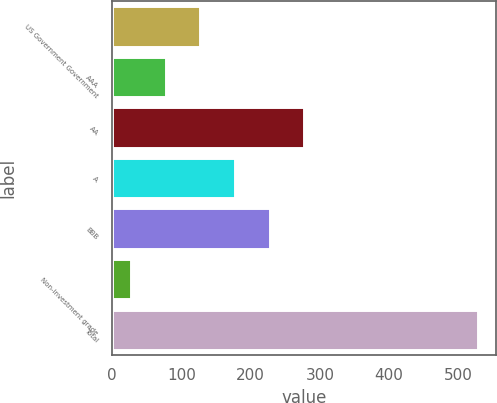Convert chart. <chart><loc_0><loc_0><loc_500><loc_500><bar_chart><fcel>US Government Government<fcel>AAA<fcel>AA<fcel>A<fcel>BBB<fcel>Non-investment grade<fcel>Total<nl><fcel>127.2<fcel>77.1<fcel>277.5<fcel>177.3<fcel>227.4<fcel>27<fcel>528<nl></chart> 